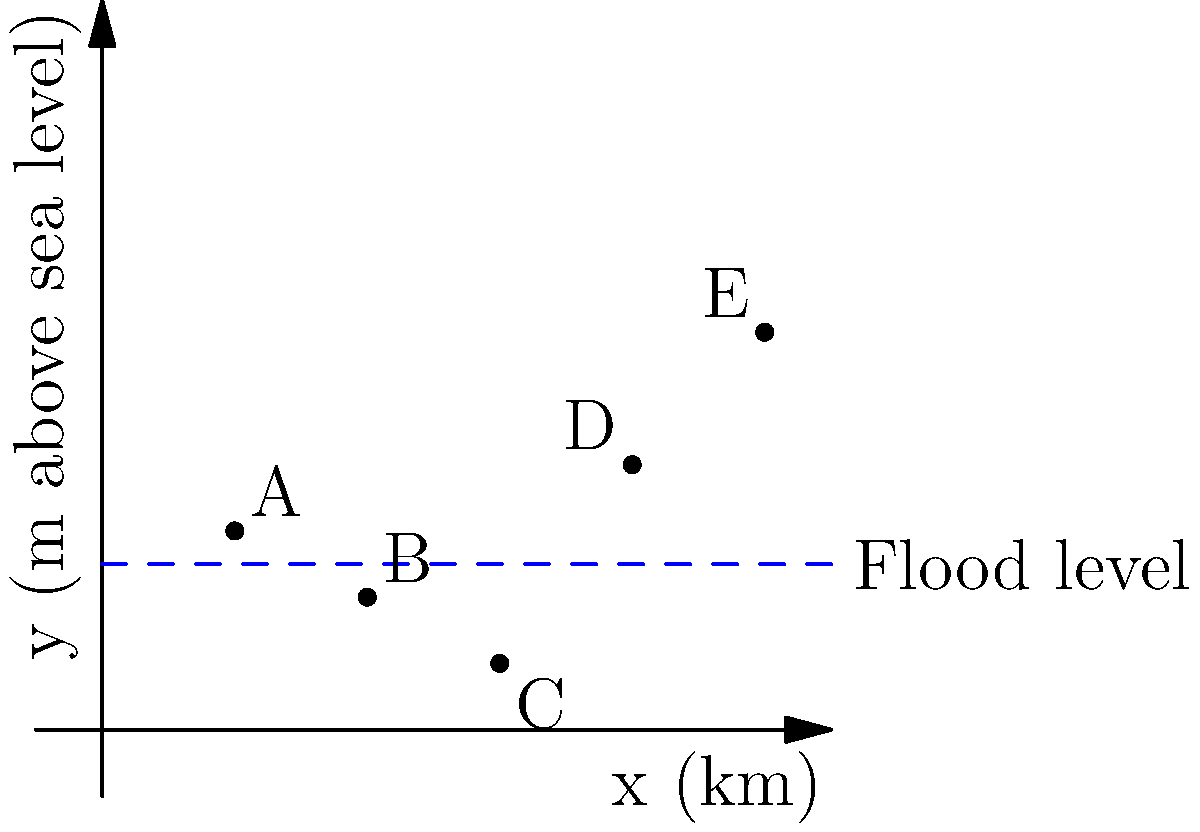The graph shows elevation points along a 10 km stretch of land in your community. Points A, B, C, D, and E represent different locations with their respective elevations above sea level. The blue dashed line indicates the predicted flood level. Which points are at risk of flooding, and what is the total distance covered by the potential flood zone? To solve this problem, we need to follow these steps:

1. Identify the flood level: The blue dashed line represents the flood level at 2.5 meters above sea level.

2. Compare each point's elevation to the flood level:
   A (2 km, 3 m): Above flood level
   B (4 km, 2 m): Below flood level
   C (6 km, 1 m): Below flood level
   D (8 km, 4 m): Above flood level
   E (10 km, 6 m): Above flood level

3. Determine the points at risk of flooding:
   Points B and C are below the flood level, so they are at risk.

4. Calculate the distance covered by the potential flood zone:
   The flood zone starts somewhere between A and B, and ends between C and D.
   We can approximate the flood zone as the distance between B and C.
   Distance = 6 km - 4 km = 2 km

Therefore, points B and C are at risk of flooding, and the potential flood zone covers approximately 2 km.
Answer: Points B and C; 2 km 